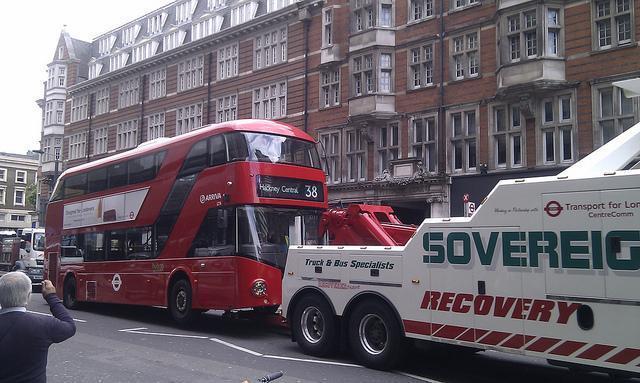How many buses are there?
Give a very brief answer. 1. How many brown horses are in the grass?
Give a very brief answer. 0. 